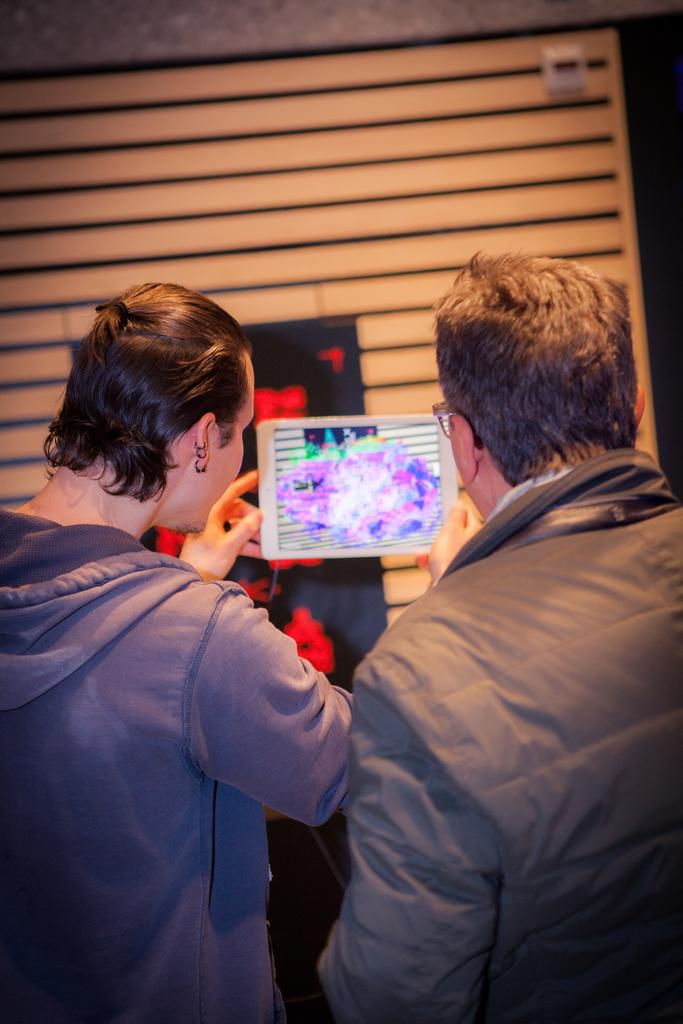What is the person in the image holding? The person is holding an iPad in the image. How is the person holding the iPad? The person is holding the iPad in his hand. Can you describe the other person in the image? There is another person beside the first person. What are both people doing in the image? Both people are looking at the iPad. What can be seen in the background of the image? There is a wall in the background of the image. Can you see any blood on the person's hands in the image? There is no blood visible on the person's hands in the image. What form does the iPad take in the image? The iPad is in its usual rectangular form in the image. 